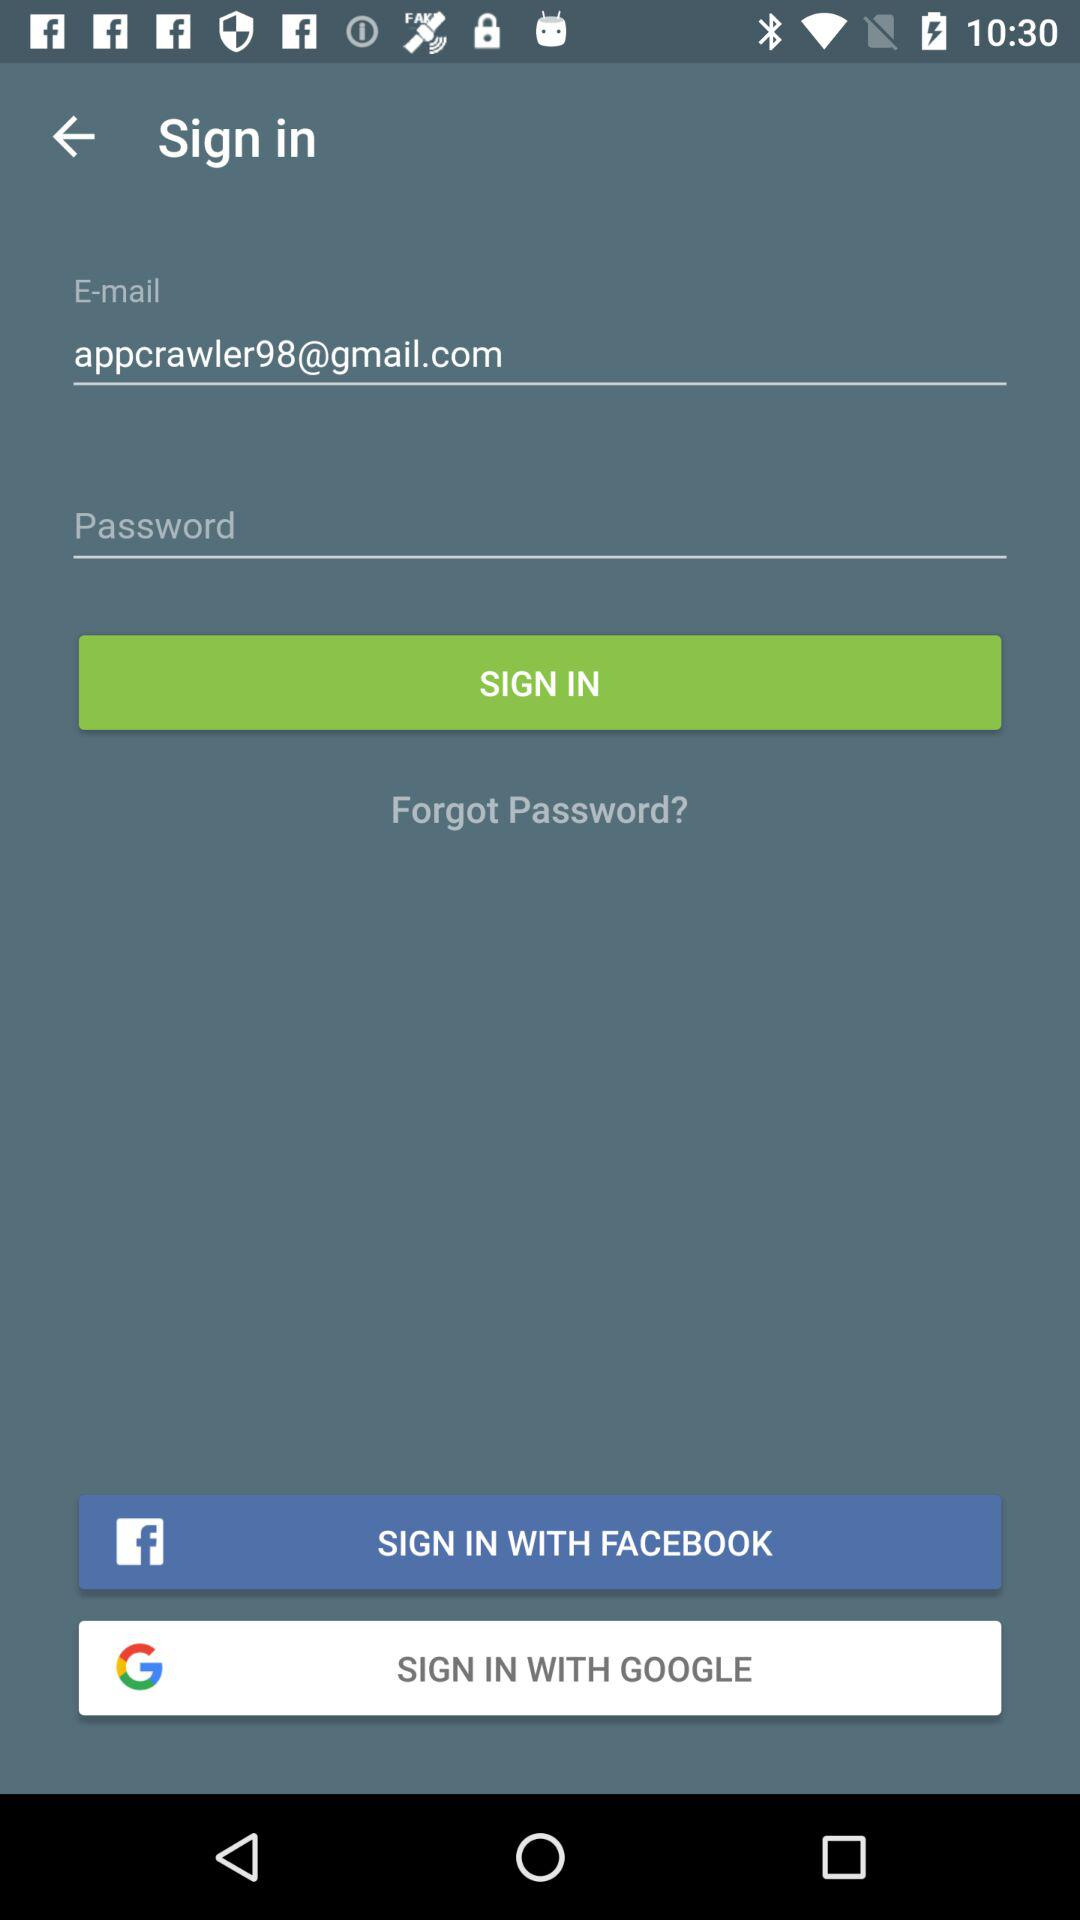What Gmail address is being used? The Gmail address that is being used is appcrawler98@gmail.com. 